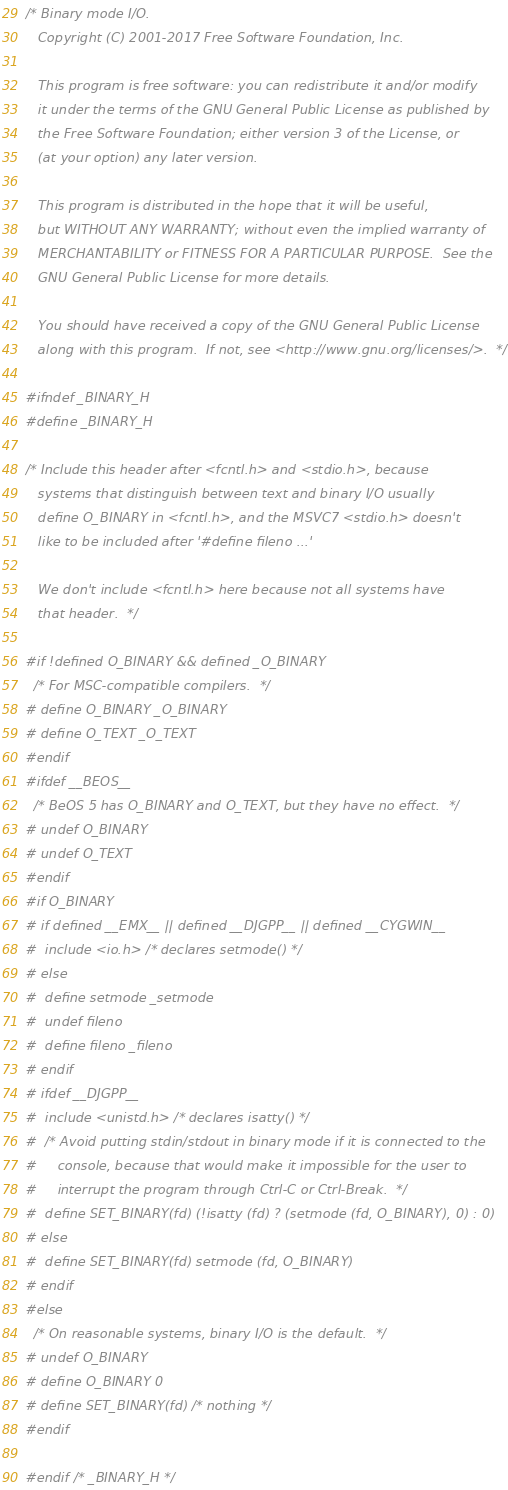<code> <loc_0><loc_0><loc_500><loc_500><_C_>/* Binary mode I/O.
   Copyright (C) 2001-2017 Free Software Foundation, Inc.

   This program is free software: you can redistribute it and/or modify
   it under the terms of the GNU General Public License as published by
   the Free Software Foundation; either version 3 of the License, or
   (at your option) any later version.

   This program is distributed in the hope that it will be useful,
   but WITHOUT ANY WARRANTY; without even the implied warranty of
   MERCHANTABILITY or FITNESS FOR A PARTICULAR PURPOSE.  See the
   GNU General Public License for more details.

   You should have received a copy of the GNU General Public License
   along with this program.  If not, see <http://www.gnu.org/licenses/>.  */

#ifndef _BINARY_H
#define _BINARY_H

/* Include this header after <fcntl.h> and <stdio.h>, because
   systems that distinguish between text and binary I/O usually
   define O_BINARY in <fcntl.h>, and the MSVC7 <stdio.h> doesn't
   like to be included after '#define fileno ...'

   We don't include <fcntl.h> here because not all systems have
   that header.  */

#if !defined O_BINARY && defined _O_BINARY
  /* For MSC-compatible compilers.  */
# define O_BINARY _O_BINARY
# define O_TEXT _O_TEXT
#endif
#ifdef __BEOS__
  /* BeOS 5 has O_BINARY and O_TEXT, but they have no effect.  */
# undef O_BINARY
# undef O_TEXT
#endif
#if O_BINARY
# if defined __EMX__ || defined __DJGPP__ || defined __CYGWIN__
#  include <io.h> /* declares setmode() */
# else
#  define setmode _setmode
#  undef fileno
#  define fileno _fileno
# endif
# ifdef __DJGPP__
#  include <unistd.h> /* declares isatty() */
#  /* Avoid putting stdin/stdout in binary mode if it is connected to the
#     console, because that would make it impossible for the user to
#     interrupt the program through Ctrl-C or Ctrl-Break.  */
#  define SET_BINARY(fd) (!isatty (fd) ? (setmode (fd, O_BINARY), 0) : 0)
# else
#  define SET_BINARY(fd) setmode (fd, O_BINARY)
# endif
#else
  /* On reasonable systems, binary I/O is the default.  */
# undef O_BINARY
# define O_BINARY 0
# define SET_BINARY(fd) /* nothing */
#endif

#endif /* _BINARY_H */
</code> 